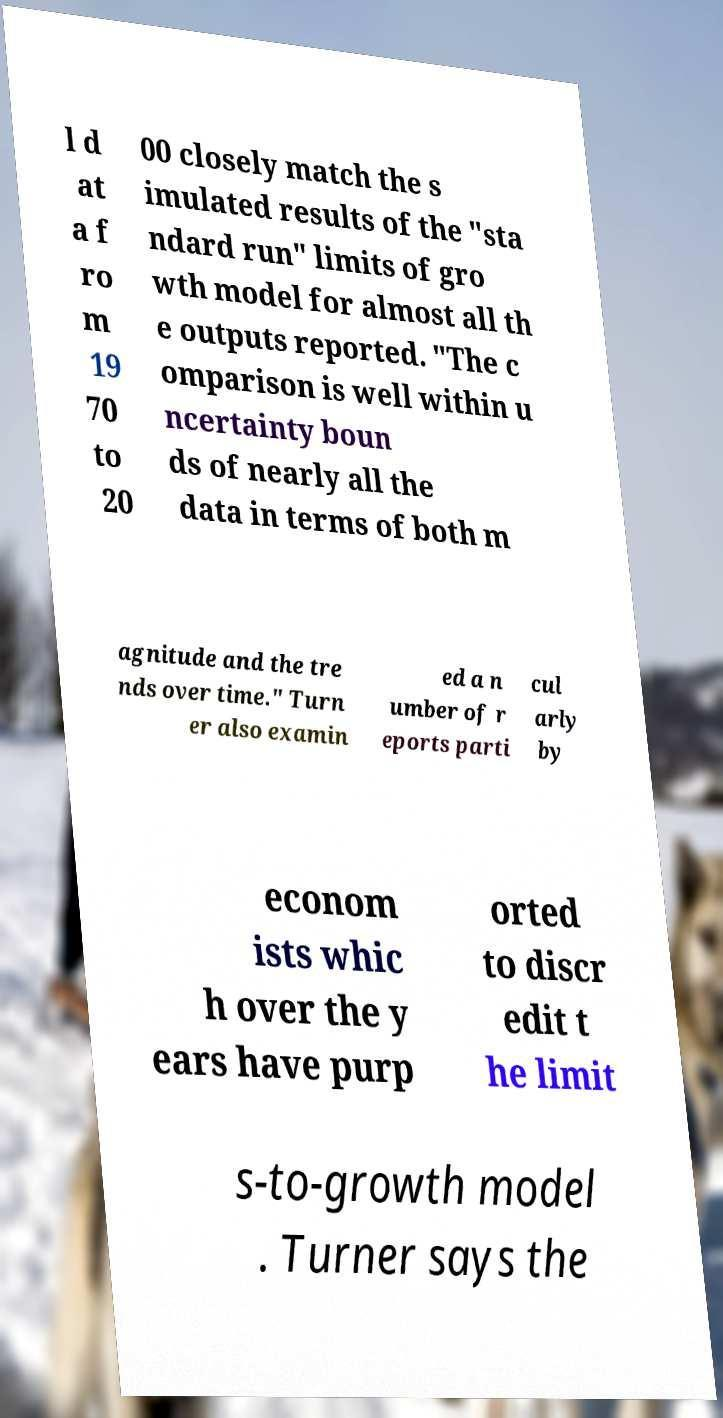Please identify and transcribe the text found in this image. l d at a f ro m 19 70 to 20 00 closely match the s imulated results of the "sta ndard run" limits of gro wth model for almost all th e outputs reported. "The c omparison is well within u ncertainty boun ds of nearly all the data in terms of both m agnitude and the tre nds over time." Turn er also examin ed a n umber of r eports parti cul arly by econom ists whic h over the y ears have purp orted to discr edit t he limit s-to-growth model . Turner says the 